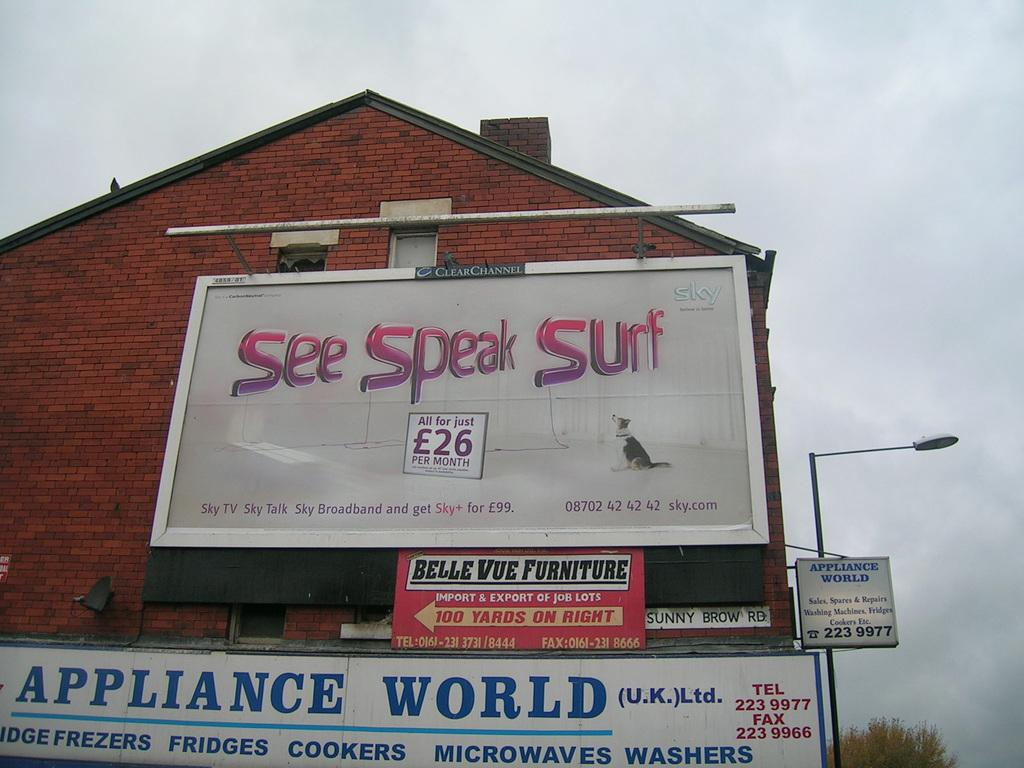<image>
Give a short and clear explanation of the subsequent image. A sign advertising TV, phone and internet for 99 pounds a month 